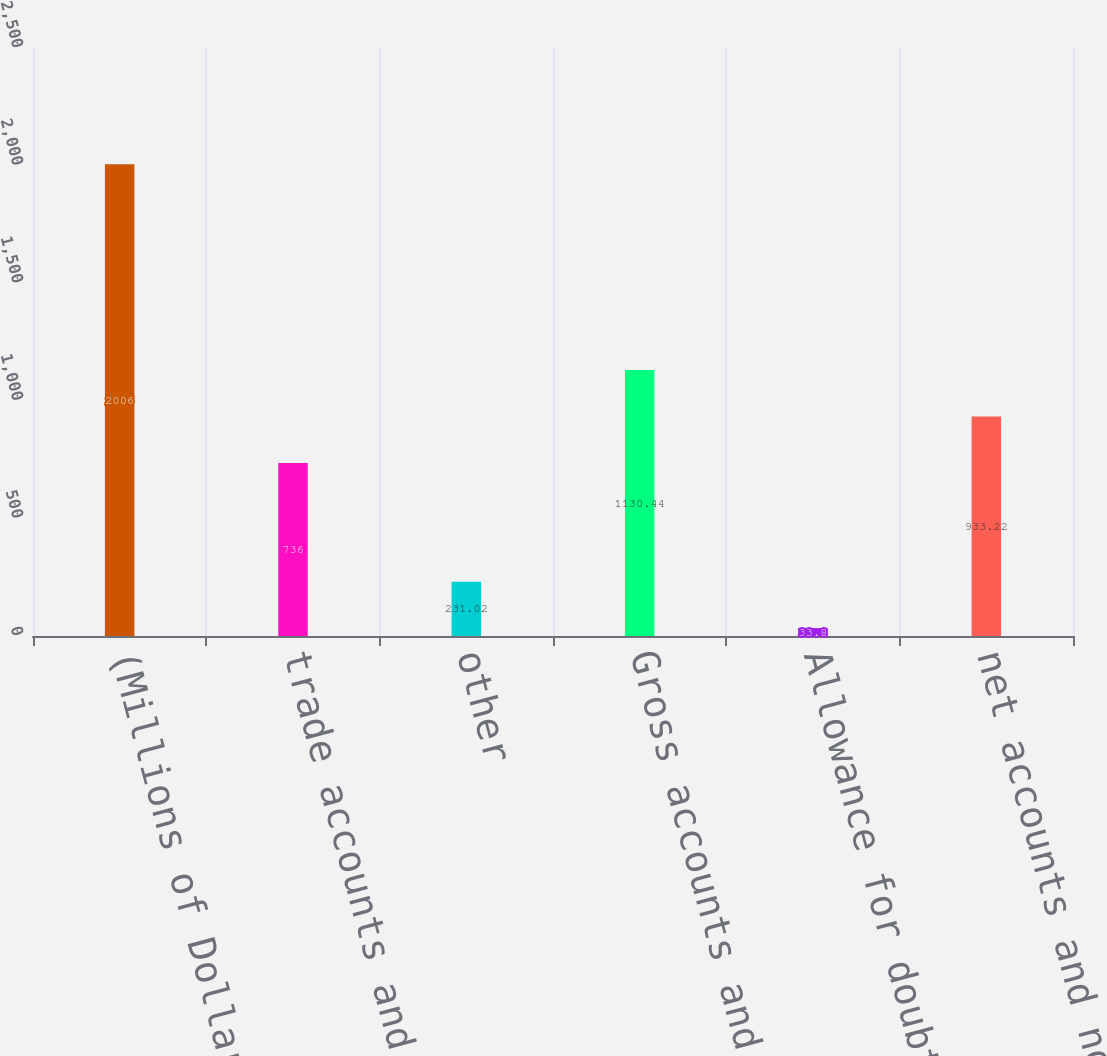Convert chart. <chart><loc_0><loc_0><loc_500><loc_500><bar_chart><fcel>(Millions of Dollars)<fcel>trade accounts and notes<fcel>other<fcel>Gross accounts and notes<fcel>Allowance for doubtful<fcel>net accounts and notes<nl><fcel>2006<fcel>736<fcel>231.02<fcel>1130.44<fcel>33.8<fcel>933.22<nl></chart> 